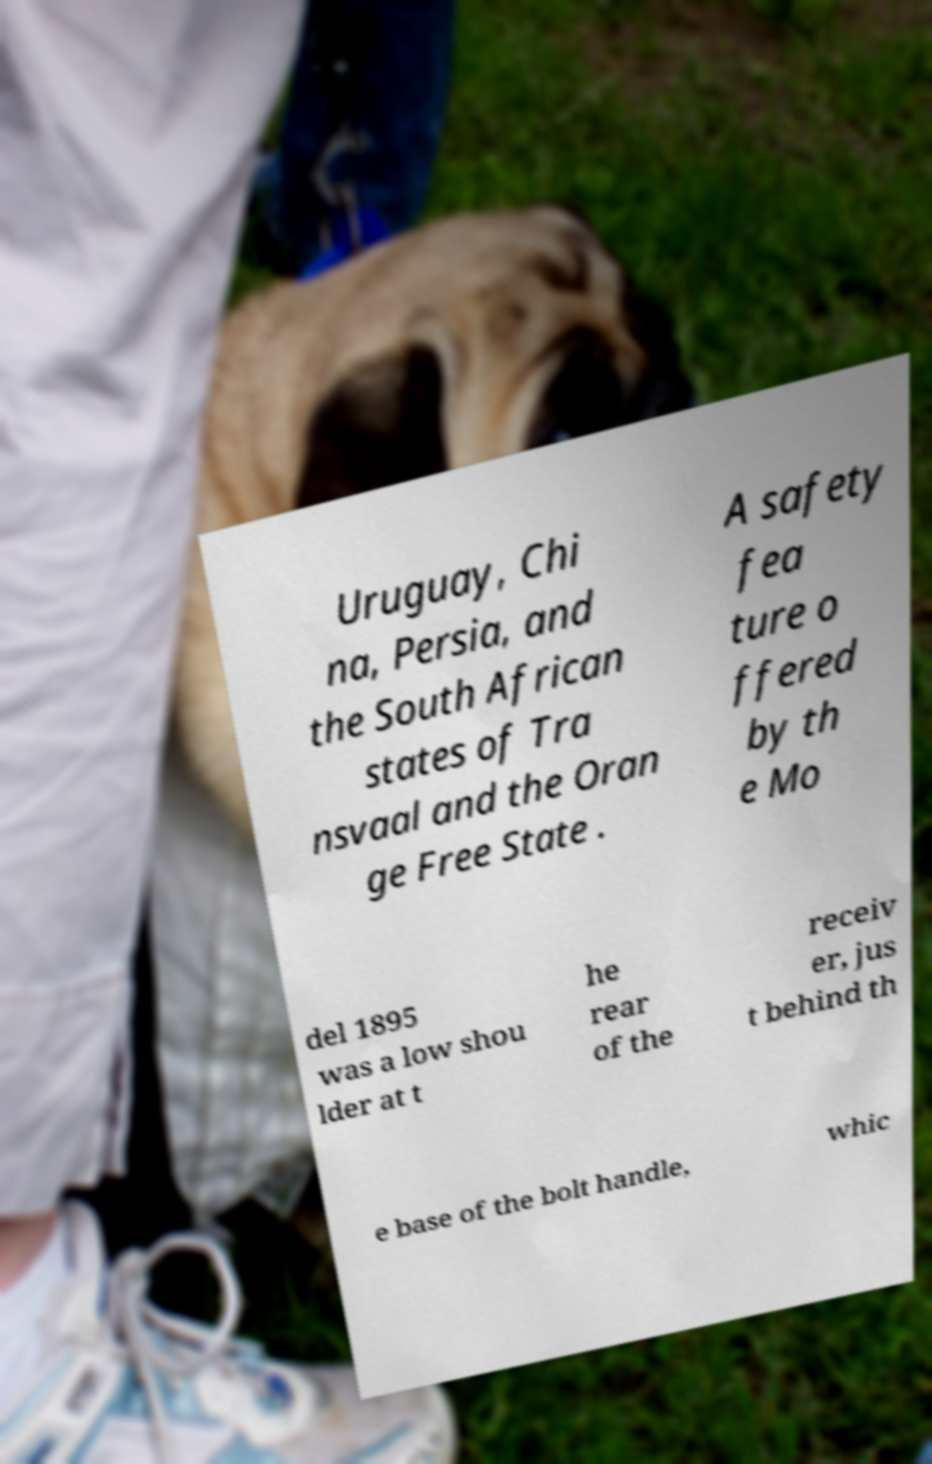Please identify and transcribe the text found in this image. Uruguay, Chi na, Persia, and the South African states of Tra nsvaal and the Oran ge Free State . A safety fea ture o ffered by th e Mo del 1895 was a low shou lder at t he rear of the receiv er, jus t behind th e base of the bolt handle, whic 